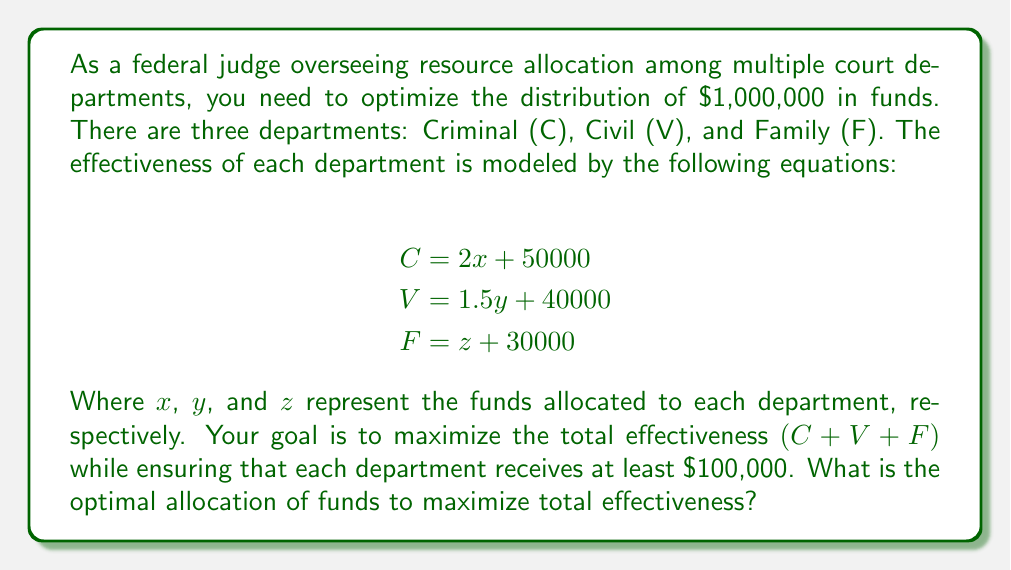Help me with this question. To solve this problem, we'll follow these steps:

1) First, let's set up the optimization problem:
   Maximize: $C + V + F = (2x + 50000) + (1.5y + 40000) + (z + 30000)$
   Subject to: $x + y + z = 1000000$ (total budget constraint)
               $x \geq 100000$, $y \geq 100000$, $z \geq 100000$ (minimum allocation constraints)

2) Simplify the objective function:
   Maximize: $2x + 1.5y + z + 120000$

3) Given the constraints and the coefficients in the objective function, we can see that to maximize the total, we should allocate as much as possible to $x$ (Criminal), then to $y$ (Civil), and lastly to $z$ (Family).

4) Start by allocating the minimum to each department:
   $x = 100000$, $y = 100000$, $z = 100000$
   Remaining funds: $1000000 - 300000 = 700000$

5) Allocate the remaining funds to $x$ (Criminal) first:
   $x = 100000 + 700000 = 800000$
   $y = 100000$
   $z = 100000$

6) Check if this allocation satisfies all constraints:
   Total allocated: $800000 + 100000 + 100000 = 1000000$ (satisfies total budget constraint)
   Each department receives at least $100,000 (satisfies minimum allocation constraints)

7) Calculate the total effectiveness:
   $C = 2(800000) + 50000 = 1650000$
   $V = 1.5(100000) + 40000 = 190000$
   $F = 100000 + 30000 = 130000$
   Total effectiveness: $1650000 + 190000 + 130000 = 1970000$

Therefore, the optimal allocation is $800,000 to Criminal, $100,000 to Civil, and $100,000 to Family departments.
Answer: Criminal: $800,000, Civil: $100,000, Family: $100,000 